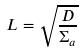Convert formula to latex. <formula><loc_0><loc_0><loc_500><loc_500>L = \sqrt { \frac { D } { \Sigma _ { a } } }</formula> 